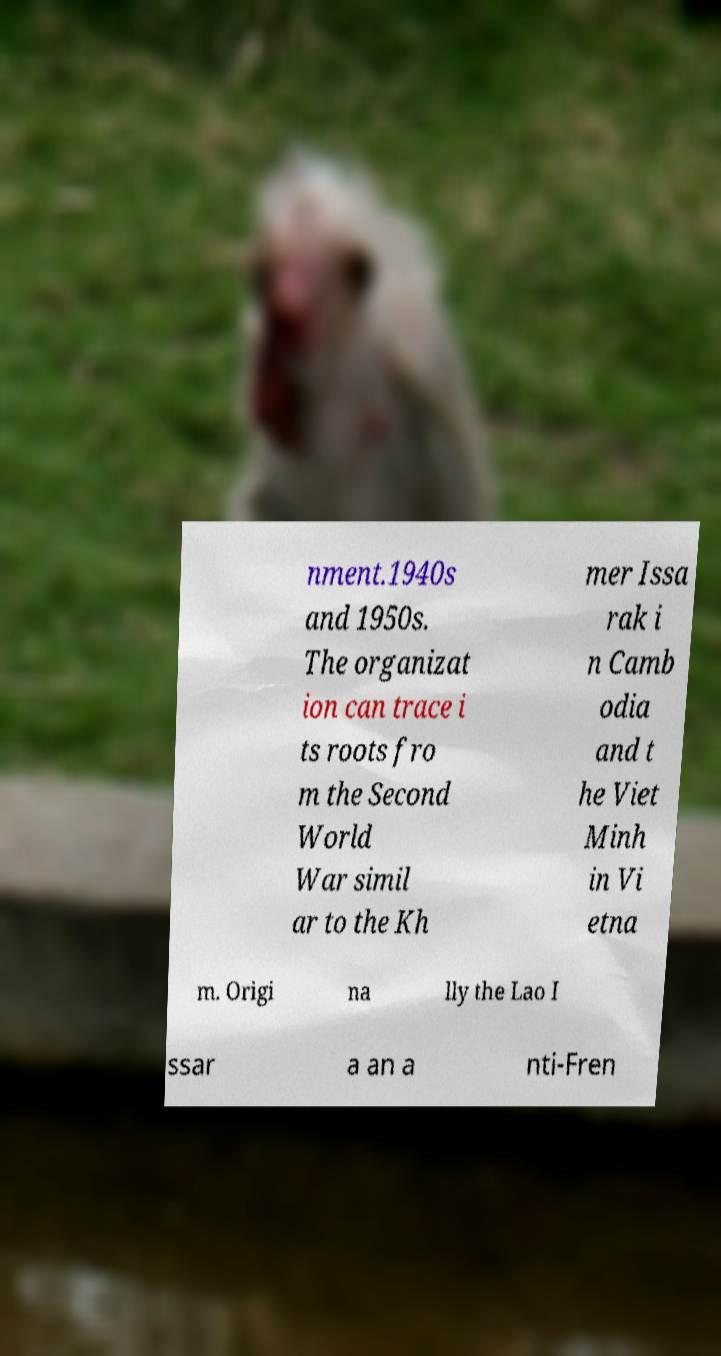What messages or text are displayed in this image? I need them in a readable, typed format. nment.1940s and 1950s. The organizat ion can trace i ts roots fro m the Second World War simil ar to the Kh mer Issa rak i n Camb odia and t he Viet Minh in Vi etna m. Origi na lly the Lao I ssar a an a nti-Fren 